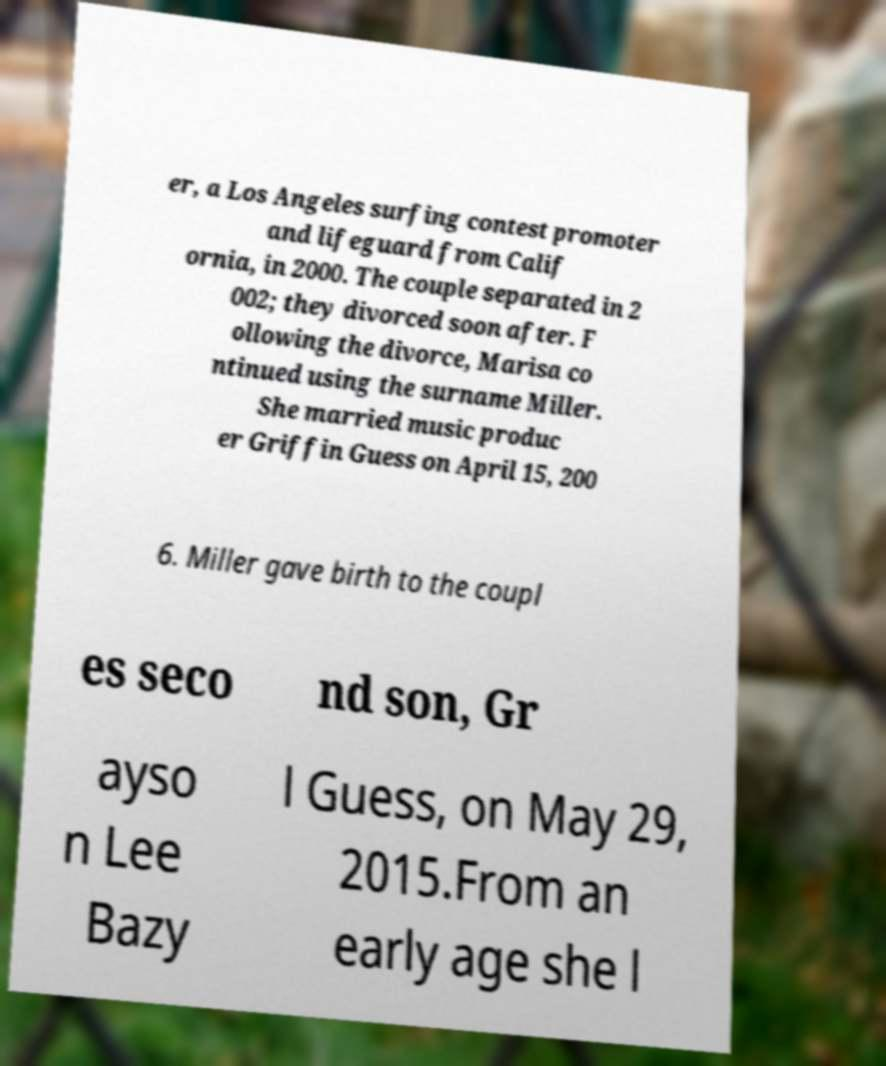Please read and relay the text visible in this image. What does it say? er, a Los Angeles surfing contest promoter and lifeguard from Calif ornia, in 2000. The couple separated in 2 002; they divorced soon after. F ollowing the divorce, Marisa co ntinued using the surname Miller. She married music produc er Griffin Guess on April 15, 200 6. Miller gave birth to the coupl es seco nd son, Gr ayso n Lee Bazy l Guess, on May 29, 2015.From an early age she l 